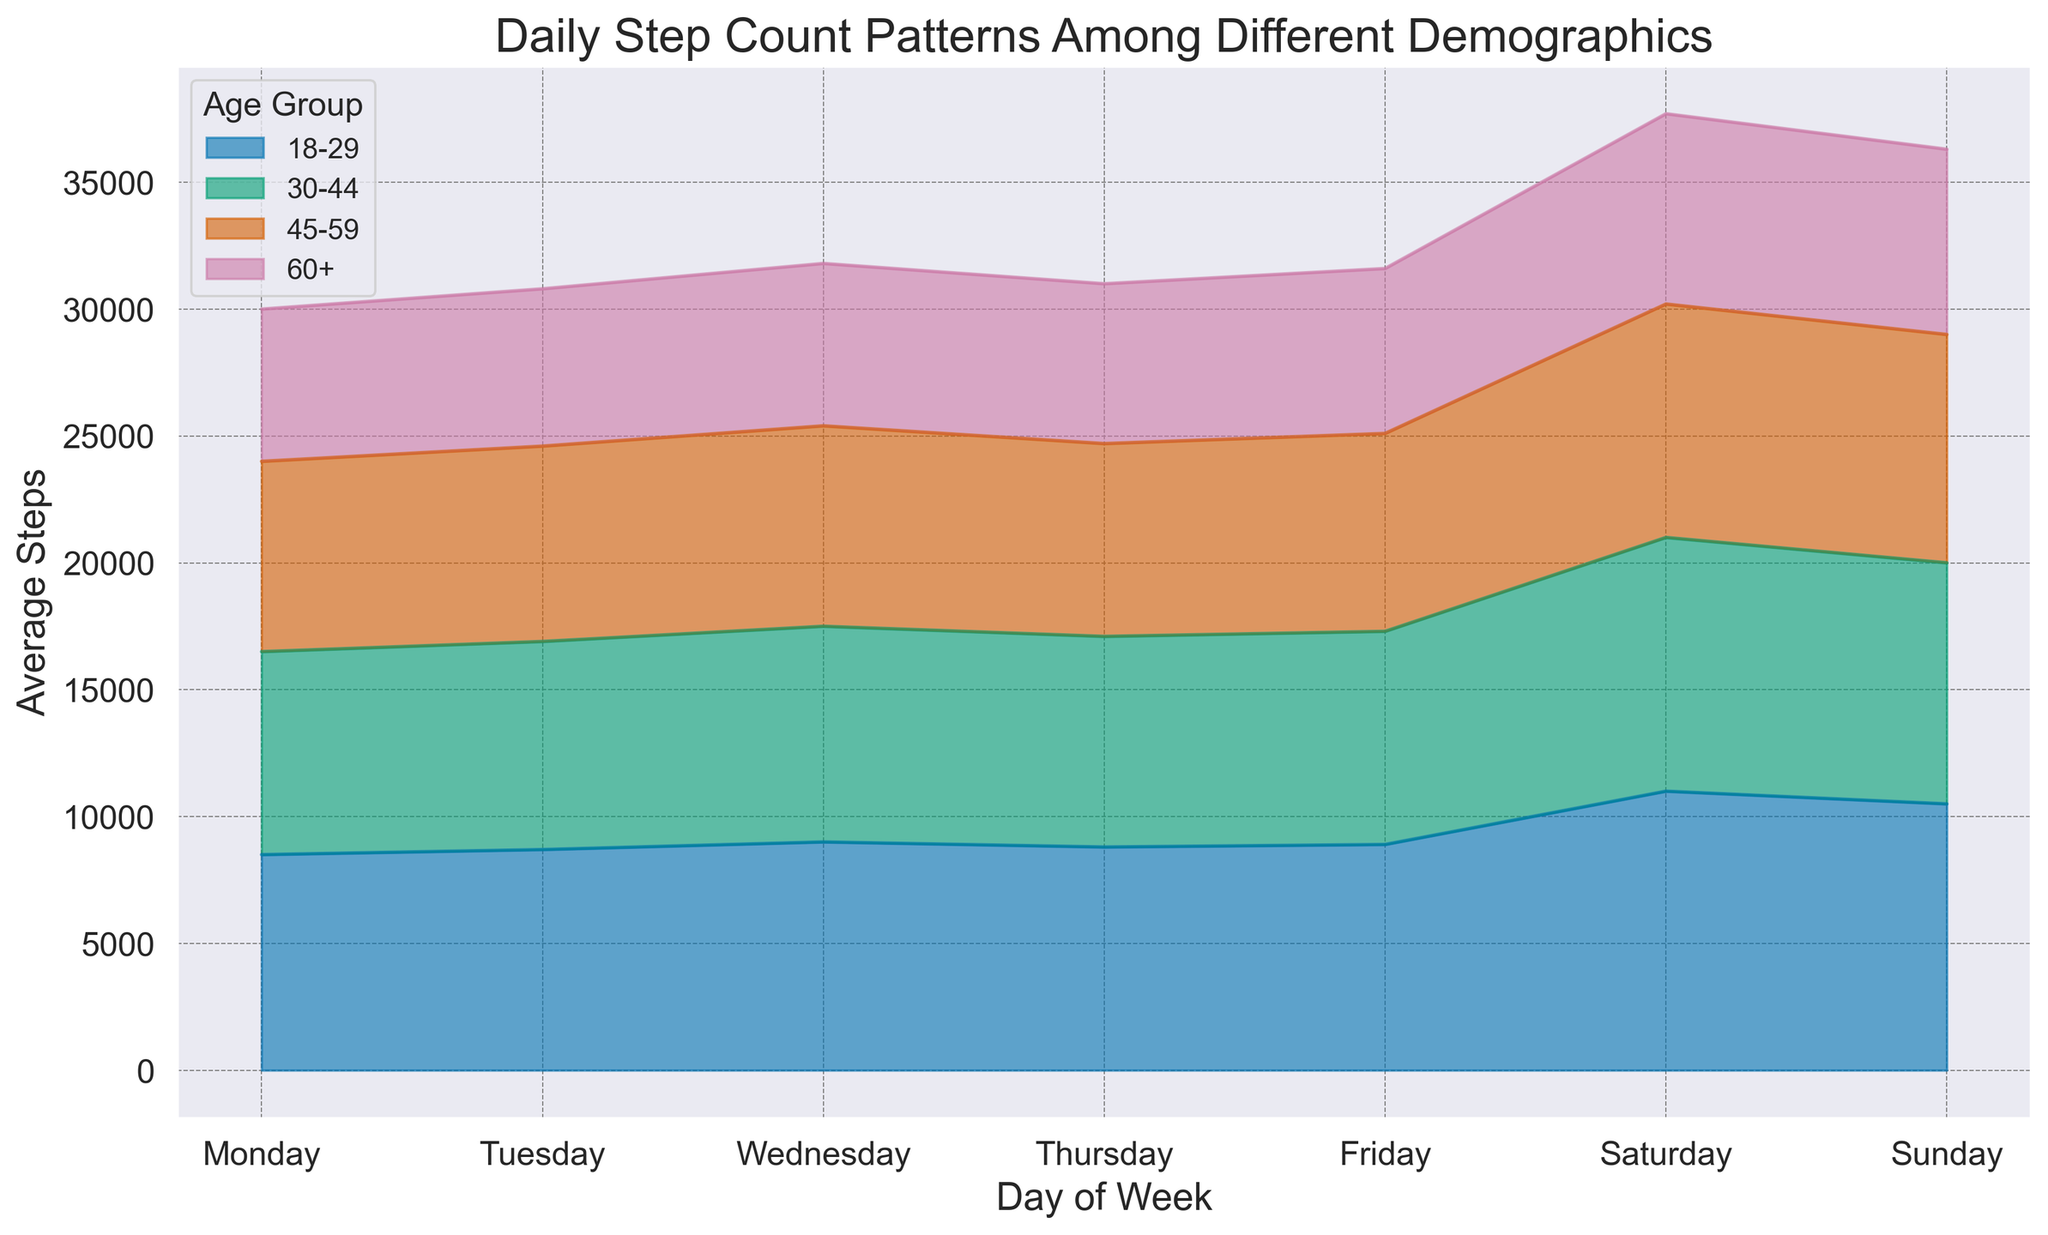What is the average step count for the 18-29 age group over the weekend (Saturday and Sunday)? To find this, sum the step counts for Saturday and Sunday for the 18-29 group (11000 + 10500) and then divide by the number of days (2). Therefore, the average is (11000 + 10500) / 2 = 10750.
Answer: 10750 Which age group has the highest average step count on Wednesdays? To answer this, visually compare the heights of the areas corresponding to Wednesdays for all age groups. The 18-29 age group has the highest area height on Wednesday with 9000 steps.
Answer: 18-29 How do the average step counts compare between Monday and Friday for the 30-44 age group? Look at the average step counts for Monday (8000) and Friday (8400) for the 30-44 age group. Subtract Monday's steps from Friday's steps: 8400 - 8000 = 400. The average on Friday is 400 steps higher than on Monday.
Answer: 400 steps higher on Friday What is the total average step count for the 60+ age group from Monday to Wednesday? Add the average step counts for Monday (6000), Tuesday (6200), and Wednesday (6400) in the 60+ age group and then sum them up. The total is 6000 + 6200 + 6400 = 18600.
Answer: 18600 Which day of the week shows the highest activity level for all ages combined? To answer this, examine the plot and sum the heights of all the age groups for each day. Saturday has the greatest combined height of areas, implying the highest activity level across all ages.
Answer: Saturday How much higher is the average step count of the 18-29 age group compared to the 60+ age group on Saturdays? On Saturday, the average step count for 18-29 is 11000 and for 60+ it's 7500. Subtract 7500 steps from 11000 steps: 11000 - 7500 = 3500.
Answer: 3500 steps higher Which age group shows the least variation in average daily step counts over the week? This can be visually assessed by observing the fluctuations in the plot. The 60+ age group has the least variation as its area remains relatively constant across the week.
Answer: 60+ On which day does the 45-59 age group have their peak average step count? Identify the day with the highest area height for the 45-59 age group. The peak for the 45-59 age group is on Saturday with 9200 steps.
Answer: Saturday What is the difference in average step count between the 30-44 and 45-59 age groups on Thursdays? Look at the plot for Thursday: the 30-44 age group has 8300 steps, and the 45-59 age group has 7600 steps. The difference is 8300 - 7600 = 700.
Answer: 700 steps Are weekends generally higher in average step counts across all demographics, or are there exceptions? Observe the plot: weekends (Saturday and Sunday) show taller areas across all age groups compared to weekdays, indicating higher average step counts. There are no significant exceptions visible.
Answer: Higher on weekends 